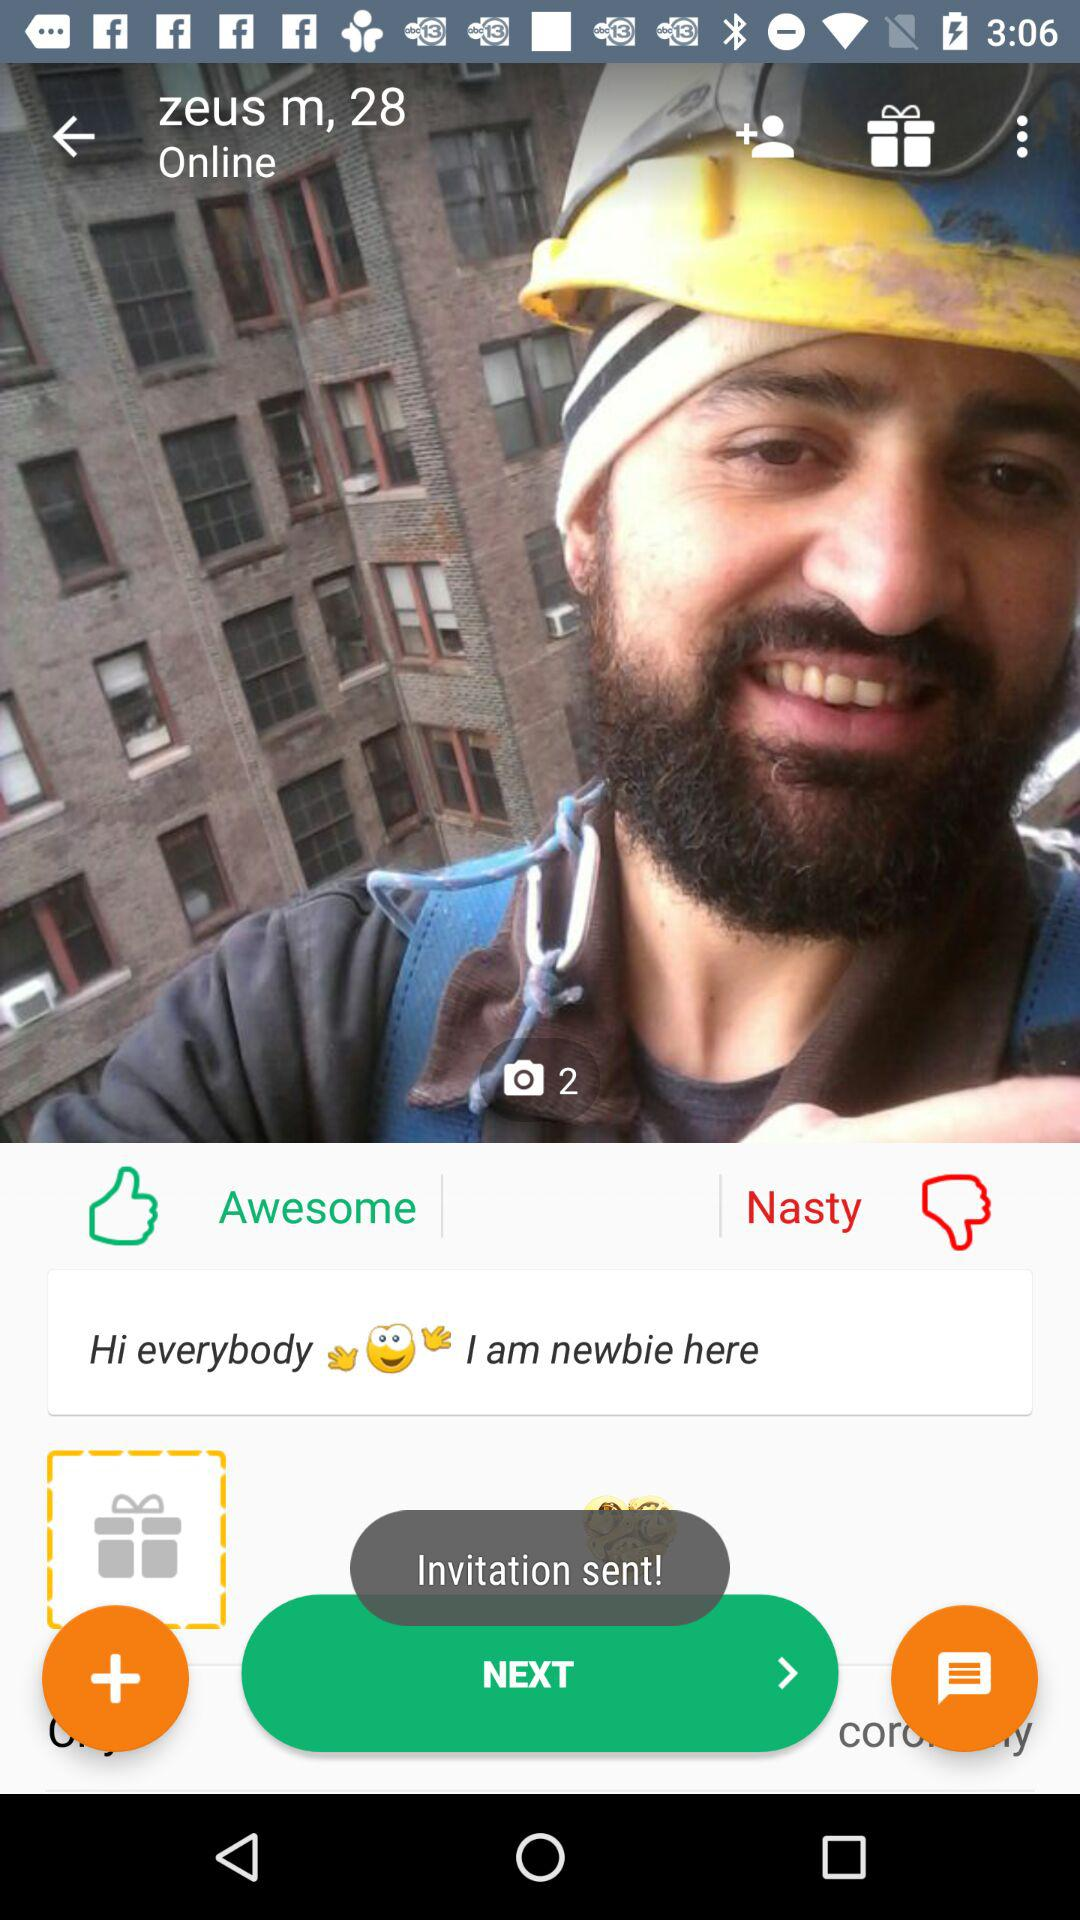What is the name of the user? The name of the user is Zeus. 